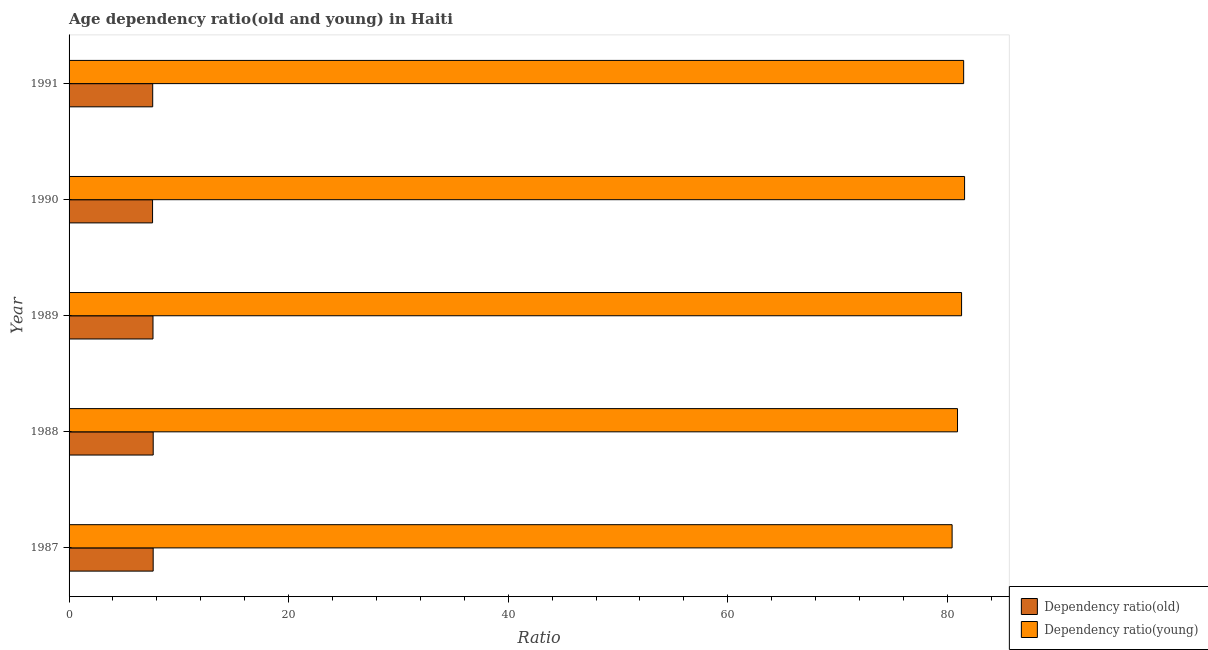How many groups of bars are there?
Make the answer very short. 5. Are the number of bars per tick equal to the number of legend labels?
Ensure brevity in your answer.  Yes. How many bars are there on the 2nd tick from the top?
Your answer should be very brief. 2. What is the label of the 1st group of bars from the top?
Give a very brief answer. 1991. In how many cases, is the number of bars for a given year not equal to the number of legend labels?
Offer a terse response. 0. What is the age dependency ratio(old) in 1991?
Offer a very short reply. 7.62. Across all years, what is the maximum age dependency ratio(young)?
Your answer should be compact. 81.57. Across all years, what is the minimum age dependency ratio(old)?
Your answer should be compact. 7.61. In which year was the age dependency ratio(old) maximum?
Offer a terse response. 1988. What is the total age dependency ratio(young) in the graph?
Give a very brief answer. 405.74. What is the difference between the age dependency ratio(young) in 1987 and that in 1989?
Ensure brevity in your answer.  -0.86. What is the difference between the age dependency ratio(young) in 1987 and the age dependency ratio(old) in 1991?
Provide a succinct answer. 72.82. What is the average age dependency ratio(young) per year?
Keep it short and to the point. 81.15. In the year 1988, what is the difference between the age dependency ratio(old) and age dependency ratio(young)?
Provide a succinct answer. -73.27. What is the ratio of the age dependency ratio(old) in 1988 to that in 1990?
Provide a succinct answer. 1.01. Is the age dependency ratio(young) in 1989 less than that in 1990?
Give a very brief answer. Yes. What is the difference between the highest and the second highest age dependency ratio(old)?
Make the answer very short. 0. What is the difference between the highest and the lowest age dependency ratio(young)?
Provide a short and direct response. 1.14. What does the 1st bar from the top in 1991 represents?
Give a very brief answer. Dependency ratio(young). What does the 2nd bar from the bottom in 1989 represents?
Provide a short and direct response. Dependency ratio(young). How many bars are there?
Offer a very short reply. 10. Are all the bars in the graph horizontal?
Provide a succinct answer. Yes. How many years are there in the graph?
Your answer should be very brief. 5. Does the graph contain grids?
Provide a succinct answer. No. Where does the legend appear in the graph?
Ensure brevity in your answer.  Bottom right. How are the legend labels stacked?
Make the answer very short. Vertical. What is the title of the graph?
Your answer should be very brief. Age dependency ratio(old and young) in Haiti. Does "Male entrants" appear as one of the legend labels in the graph?
Give a very brief answer. No. What is the label or title of the X-axis?
Your response must be concise. Ratio. What is the label or title of the Y-axis?
Your response must be concise. Year. What is the Ratio of Dependency ratio(old) in 1987?
Offer a very short reply. 7.66. What is the Ratio of Dependency ratio(young) in 1987?
Keep it short and to the point. 80.44. What is the Ratio of Dependency ratio(old) in 1988?
Your response must be concise. 7.66. What is the Ratio of Dependency ratio(young) in 1988?
Provide a succinct answer. 80.93. What is the Ratio of Dependency ratio(old) in 1989?
Make the answer very short. 7.64. What is the Ratio of Dependency ratio(young) in 1989?
Give a very brief answer. 81.3. What is the Ratio of Dependency ratio(old) in 1990?
Provide a short and direct response. 7.61. What is the Ratio of Dependency ratio(young) in 1990?
Your response must be concise. 81.57. What is the Ratio in Dependency ratio(old) in 1991?
Ensure brevity in your answer.  7.62. What is the Ratio in Dependency ratio(young) in 1991?
Ensure brevity in your answer.  81.49. Across all years, what is the maximum Ratio of Dependency ratio(old)?
Your response must be concise. 7.66. Across all years, what is the maximum Ratio in Dependency ratio(young)?
Your response must be concise. 81.57. Across all years, what is the minimum Ratio in Dependency ratio(old)?
Your answer should be very brief. 7.61. Across all years, what is the minimum Ratio of Dependency ratio(young)?
Ensure brevity in your answer.  80.44. What is the total Ratio in Dependency ratio(old) in the graph?
Keep it short and to the point. 38.19. What is the total Ratio in Dependency ratio(young) in the graph?
Ensure brevity in your answer.  405.74. What is the difference between the Ratio in Dependency ratio(old) in 1987 and that in 1988?
Your response must be concise. -0. What is the difference between the Ratio in Dependency ratio(young) in 1987 and that in 1988?
Your answer should be very brief. -0.49. What is the difference between the Ratio in Dependency ratio(old) in 1987 and that in 1989?
Keep it short and to the point. 0.02. What is the difference between the Ratio in Dependency ratio(young) in 1987 and that in 1989?
Make the answer very short. -0.86. What is the difference between the Ratio of Dependency ratio(old) in 1987 and that in 1990?
Your answer should be compact. 0.06. What is the difference between the Ratio of Dependency ratio(young) in 1987 and that in 1990?
Offer a terse response. -1.14. What is the difference between the Ratio of Dependency ratio(old) in 1987 and that in 1991?
Ensure brevity in your answer.  0.04. What is the difference between the Ratio of Dependency ratio(young) in 1987 and that in 1991?
Keep it short and to the point. -1.05. What is the difference between the Ratio of Dependency ratio(old) in 1988 and that in 1989?
Provide a succinct answer. 0.02. What is the difference between the Ratio in Dependency ratio(young) in 1988 and that in 1989?
Keep it short and to the point. -0.37. What is the difference between the Ratio of Dependency ratio(old) in 1988 and that in 1990?
Keep it short and to the point. 0.06. What is the difference between the Ratio of Dependency ratio(young) in 1988 and that in 1990?
Offer a very short reply. -0.64. What is the difference between the Ratio in Dependency ratio(old) in 1988 and that in 1991?
Keep it short and to the point. 0.05. What is the difference between the Ratio in Dependency ratio(young) in 1988 and that in 1991?
Give a very brief answer. -0.56. What is the difference between the Ratio of Dependency ratio(old) in 1989 and that in 1990?
Keep it short and to the point. 0.04. What is the difference between the Ratio of Dependency ratio(young) in 1989 and that in 1990?
Your response must be concise. -0.27. What is the difference between the Ratio in Dependency ratio(old) in 1989 and that in 1991?
Your answer should be compact. 0.03. What is the difference between the Ratio of Dependency ratio(young) in 1989 and that in 1991?
Give a very brief answer. -0.19. What is the difference between the Ratio in Dependency ratio(old) in 1990 and that in 1991?
Make the answer very short. -0.01. What is the difference between the Ratio of Dependency ratio(young) in 1990 and that in 1991?
Your answer should be very brief. 0.08. What is the difference between the Ratio in Dependency ratio(old) in 1987 and the Ratio in Dependency ratio(young) in 1988?
Keep it short and to the point. -73.27. What is the difference between the Ratio in Dependency ratio(old) in 1987 and the Ratio in Dependency ratio(young) in 1989?
Your answer should be very brief. -73.64. What is the difference between the Ratio of Dependency ratio(old) in 1987 and the Ratio of Dependency ratio(young) in 1990?
Your response must be concise. -73.91. What is the difference between the Ratio of Dependency ratio(old) in 1987 and the Ratio of Dependency ratio(young) in 1991?
Ensure brevity in your answer.  -73.83. What is the difference between the Ratio of Dependency ratio(old) in 1988 and the Ratio of Dependency ratio(young) in 1989?
Ensure brevity in your answer.  -73.64. What is the difference between the Ratio of Dependency ratio(old) in 1988 and the Ratio of Dependency ratio(young) in 1990?
Keep it short and to the point. -73.91. What is the difference between the Ratio in Dependency ratio(old) in 1988 and the Ratio in Dependency ratio(young) in 1991?
Provide a succinct answer. -73.83. What is the difference between the Ratio in Dependency ratio(old) in 1989 and the Ratio in Dependency ratio(young) in 1990?
Your answer should be very brief. -73.93. What is the difference between the Ratio of Dependency ratio(old) in 1989 and the Ratio of Dependency ratio(young) in 1991?
Offer a terse response. -73.85. What is the difference between the Ratio of Dependency ratio(old) in 1990 and the Ratio of Dependency ratio(young) in 1991?
Provide a short and direct response. -73.88. What is the average Ratio of Dependency ratio(old) per year?
Provide a short and direct response. 7.64. What is the average Ratio of Dependency ratio(young) per year?
Provide a short and direct response. 81.15. In the year 1987, what is the difference between the Ratio in Dependency ratio(old) and Ratio in Dependency ratio(young)?
Offer a terse response. -72.78. In the year 1988, what is the difference between the Ratio in Dependency ratio(old) and Ratio in Dependency ratio(young)?
Offer a terse response. -73.27. In the year 1989, what is the difference between the Ratio in Dependency ratio(old) and Ratio in Dependency ratio(young)?
Keep it short and to the point. -73.66. In the year 1990, what is the difference between the Ratio of Dependency ratio(old) and Ratio of Dependency ratio(young)?
Offer a terse response. -73.97. In the year 1991, what is the difference between the Ratio in Dependency ratio(old) and Ratio in Dependency ratio(young)?
Your answer should be compact. -73.87. What is the ratio of the Ratio in Dependency ratio(old) in 1987 to that in 1988?
Your response must be concise. 1. What is the ratio of the Ratio in Dependency ratio(young) in 1987 to that in 1988?
Your response must be concise. 0.99. What is the ratio of the Ratio in Dependency ratio(old) in 1987 to that in 1990?
Offer a terse response. 1.01. What is the ratio of the Ratio of Dependency ratio(young) in 1987 to that in 1990?
Your answer should be very brief. 0.99. What is the ratio of the Ratio of Dependency ratio(young) in 1987 to that in 1991?
Provide a short and direct response. 0.99. What is the ratio of the Ratio of Dependency ratio(old) in 1988 to that in 1989?
Your answer should be very brief. 1. What is the ratio of the Ratio in Dependency ratio(old) in 1988 to that in 1990?
Make the answer very short. 1.01. What is the ratio of the Ratio in Dependency ratio(old) in 1988 to that in 1991?
Ensure brevity in your answer.  1.01. What is the ratio of the Ratio of Dependency ratio(old) in 1989 to that in 1990?
Make the answer very short. 1.01. What is the ratio of the Ratio in Dependency ratio(young) in 1989 to that in 1991?
Make the answer very short. 1. What is the ratio of the Ratio in Dependency ratio(old) in 1990 to that in 1991?
Keep it short and to the point. 1. What is the ratio of the Ratio of Dependency ratio(young) in 1990 to that in 1991?
Make the answer very short. 1. What is the difference between the highest and the second highest Ratio of Dependency ratio(old)?
Ensure brevity in your answer.  0. What is the difference between the highest and the second highest Ratio of Dependency ratio(young)?
Your answer should be compact. 0.08. What is the difference between the highest and the lowest Ratio in Dependency ratio(old)?
Provide a short and direct response. 0.06. What is the difference between the highest and the lowest Ratio of Dependency ratio(young)?
Keep it short and to the point. 1.14. 